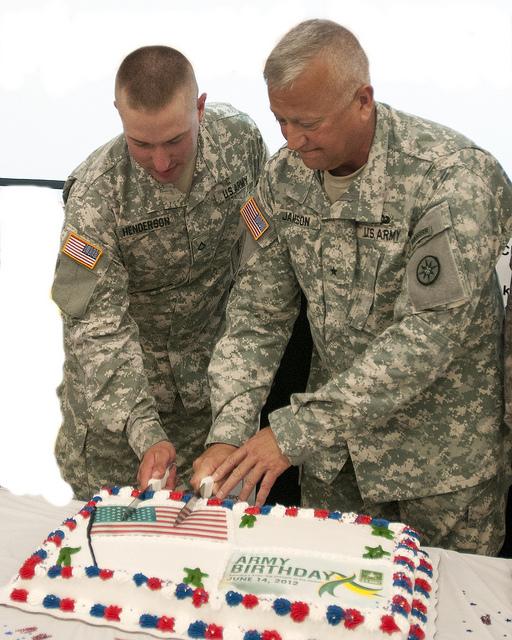Are these both young men?
Be succinct. No. Whose birthday is it?
Keep it brief. Army. What is on the table?
Be succinct. Cake. 